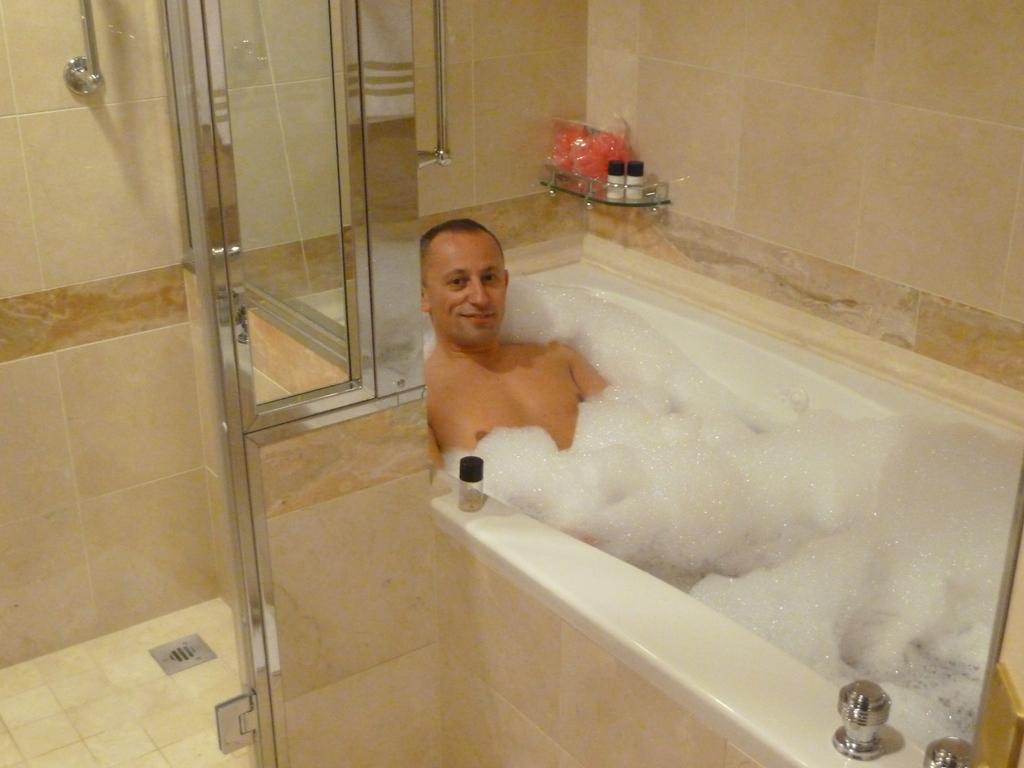What is located on the left side of the image? There is a glass door on the left side of the image. What can be seen in the middle of the image? There is a man in a bathtub in the middle of the image. What is present in the bathroom stand? There are objects in the bathroom stand. What is visible in the background of the image? There is a wall visible in the image. What type of flag is hanging on the wall in the image? There is no flag present in the image; it features a man in a bathtub and a glass door. Can you see any bees flying around the bathroom in the image? There are no bees visible in the image. 